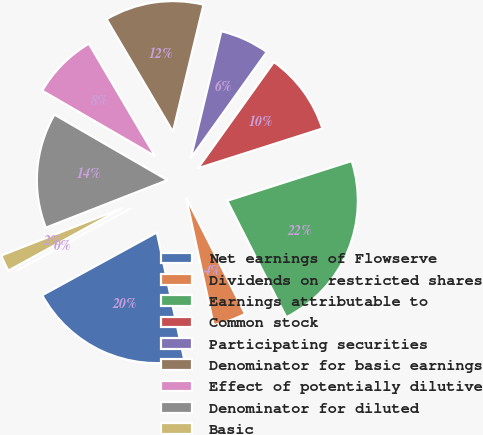<chart> <loc_0><loc_0><loc_500><loc_500><pie_chart><fcel>Net earnings of Flowserve<fcel>Dividends on restricted shares<fcel>Earnings attributable to<fcel>Common stock<fcel>Participating securities<fcel>Denominator for basic earnings<fcel>Effect of potentially dilutive<fcel>Denominator for diluted<fcel>Basic<fcel>Diluted<nl><fcel>20.41%<fcel>4.08%<fcel>22.45%<fcel>10.2%<fcel>6.12%<fcel>12.24%<fcel>8.16%<fcel>14.29%<fcel>2.04%<fcel>0.0%<nl></chart> 